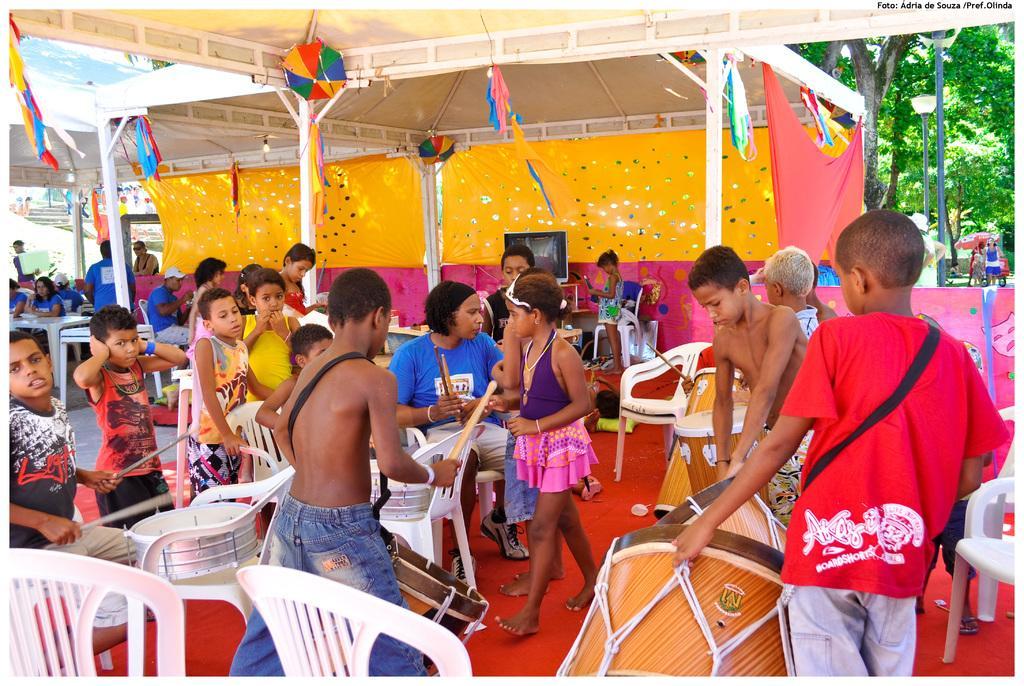Could you give a brief overview of what you see in this image? Few persons are standing and few persons are sitting on the chair. We can see musical instruments and chairs. On the background we can see tent. 